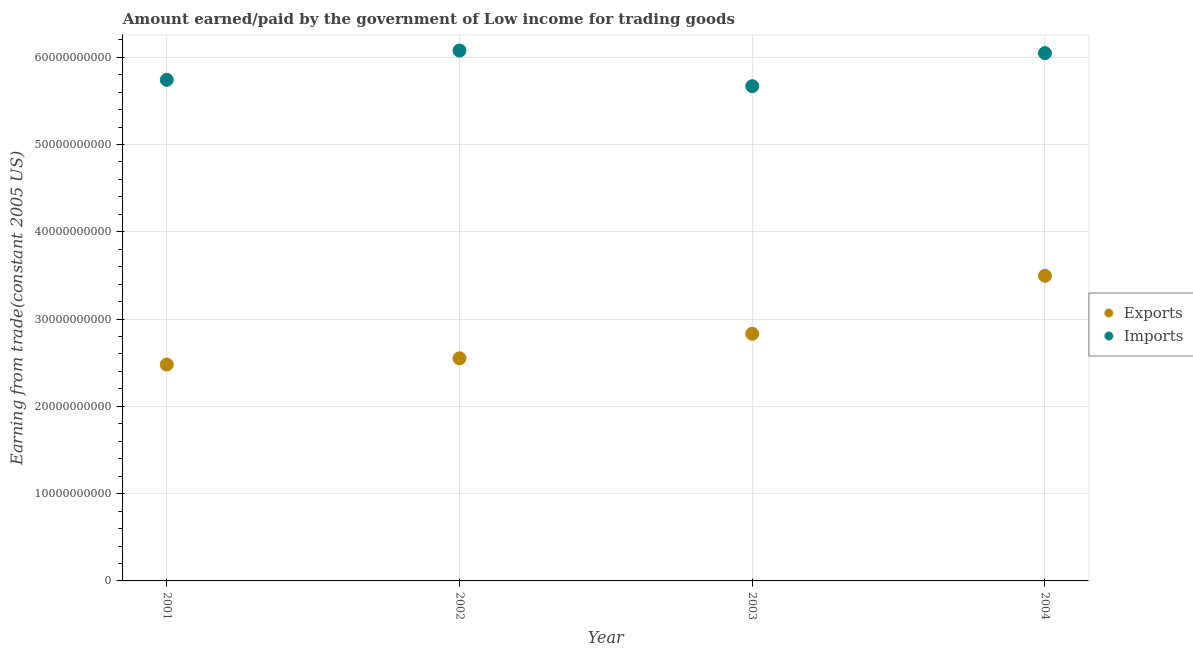What is the amount earned from exports in 2002?
Offer a terse response. 2.55e+1. Across all years, what is the maximum amount earned from exports?
Offer a very short reply. 3.50e+1. Across all years, what is the minimum amount paid for imports?
Provide a succinct answer. 5.67e+1. In which year was the amount paid for imports maximum?
Keep it short and to the point. 2002. In which year was the amount earned from exports minimum?
Provide a short and direct response. 2001. What is the total amount paid for imports in the graph?
Ensure brevity in your answer.  2.35e+11. What is the difference between the amount earned from exports in 2002 and that in 2003?
Provide a succinct answer. -2.81e+09. What is the difference between the amount paid for imports in 2003 and the amount earned from exports in 2004?
Keep it short and to the point. 2.17e+1. What is the average amount paid for imports per year?
Offer a terse response. 5.88e+1. In the year 2004, what is the difference between the amount paid for imports and amount earned from exports?
Offer a terse response. 2.55e+1. What is the ratio of the amount earned from exports in 2001 to that in 2004?
Provide a short and direct response. 0.71. Is the amount paid for imports in 2001 less than that in 2004?
Provide a succinct answer. Yes. What is the difference between the highest and the second highest amount earned from exports?
Your answer should be compact. 6.65e+09. What is the difference between the highest and the lowest amount paid for imports?
Keep it short and to the point. 4.08e+09. Is the sum of the amount paid for imports in 2002 and 2003 greater than the maximum amount earned from exports across all years?
Your response must be concise. Yes. Is the amount paid for imports strictly greater than the amount earned from exports over the years?
Make the answer very short. Yes. How many dotlines are there?
Provide a short and direct response. 2. What is the difference between two consecutive major ticks on the Y-axis?
Provide a succinct answer. 1.00e+1. How are the legend labels stacked?
Your answer should be compact. Vertical. What is the title of the graph?
Your answer should be very brief. Amount earned/paid by the government of Low income for trading goods. Does "Age 15+" appear as one of the legend labels in the graph?
Keep it short and to the point. No. What is the label or title of the X-axis?
Provide a succinct answer. Year. What is the label or title of the Y-axis?
Your answer should be very brief. Earning from trade(constant 2005 US). What is the Earning from trade(constant 2005 US) in Exports in 2001?
Offer a very short reply. 2.48e+1. What is the Earning from trade(constant 2005 US) of Imports in 2001?
Keep it short and to the point. 5.74e+1. What is the Earning from trade(constant 2005 US) of Exports in 2002?
Your answer should be very brief. 2.55e+1. What is the Earning from trade(constant 2005 US) of Imports in 2002?
Offer a terse response. 6.08e+1. What is the Earning from trade(constant 2005 US) in Exports in 2003?
Offer a terse response. 2.83e+1. What is the Earning from trade(constant 2005 US) in Imports in 2003?
Keep it short and to the point. 5.67e+1. What is the Earning from trade(constant 2005 US) in Exports in 2004?
Offer a very short reply. 3.50e+1. What is the Earning from trade(constant 2005 US) in Imports in 2004?
Offer a terse response. 6.05e+1. Across all years, what is the maximum Earning from trade(constant 2005 US) of Exports?
Provide a succinct answer. 3.50e+1. Across all years, what is the maximum Earning from trade(constant 2005 US) in Imports?
Make the answer very short. 6.08e+1. Across all years, what is the minimum Earning from trade(constant 2005 US) of Exports?
Your answer should be very brief. 2.48e+1. Across all years, what is the minimum Earning from trade(constant 2005 US) of Imports?
Provide a succinct answer. 5.67e+1. What is the total Earning from trade(constant 2005 US) in Exports in the graph?
Provide a short and direct response. 1.14e+11. What is the total Earning from trade(constant 2005 US) of Imports in the graph?
Provide a succinct answer. 2.35e+11. What is the difference between the Earning from trade(constant 2005 US) of Exports in 2001 and that in 2002?
Ensure brevity in your answer.  -7.19e+08. What is the difference between the Earning from trade(constant 2005 US) of Imports in 2001 and that in 2002?
Give a very brief answer. -3.35e+09. What is the difference between the Earning from trade(constant 2005 US) in Exports in 2001 and that in 2003?
Provide a succinct answer. -3.52e+09. What is the difference between the Earning from trade(constant 2005 US) of Imports in 2001 and that in 2003?
Keep it short and to the point. 7.26e+08. What is the difference between the Earning from trade(constant 2005 US) of Exports in 2001 and that in 2004?
Ensure brevity in your answer.  -1.02e+1. What is the difference between the Earning from trade(constant 2005 US) in Imports in 2001 and that in 2004?
Your answer should be compact. -3.06e+09. What is the difference between the Earning from trade(constant 2005 US) of Exports in 2002 and that in 2003?
Provide a short and direct response. -2.81e+09. What is the difference between the Earning from trade(constant 2005 US) in Imports in 2002 and that in 2003?
Give a very brief answer. 4.08e+09. What is the difference between the Earning from trade(constant 2005 US) in Exports in 2002 and that in 2004?
Provide a succinct answer. -9.45e+09. What is the difference between the Earning from trade(constant 2005 US) of Imports in 2002 and that in 2004?
Your response must be concise. 2.92e+08. What is the difference between the Earning from trade(constant 2005 US) of Exports in 2003 and that in 2004?
Give a very brief answer. -6.65e+09. What is the difference between the Earning from trade(constant 2005 US) of Imports in 2003 and that in 2004?
Give a very brief answer. -3.79e+09. What is the difference between the Earning from trade(constant 2005 US) in Exports in 2001 and the Earning from trade(constant 2005 US) in Imports in 2002?
Make the answer very short. -3.60e+1. What is the difference between the Earning from trade(constant 2005 US) in Exports in 2001 and the Earning from trade(constant 2005 US) in Imports in 2003?
Offer a terse response. -3.19e+1. What is the difference between the Earning from trade(constant 2005 US) in Exports in 2001 and the Earning from trade(constant 2005 US) in Imports in 2004?
Offer a very short reply. -3.57e+1. What is the difference between the Earning from trade(constant 2005 US) in Exports in 2002 and the Earning from trade(constant 2005 US) in Imports in 2003?
Make the answer very short. -3.12e+1. What is the difference between the Earning from trade(constant 2005 US) in Exports in 2002 and the Earning from trade(constant 2005 US) in Imports in 2004?
Make the answer very short. -3.50e+1. What is the difference between the Earning from trade(constant 2005 US) of Exports in 2003 and the Earning from trade(constant 2005 US) of Imports in 2004?
Offer a very short reply. -3.22e+1. What is the average Earning from trade(constant 2005 US) of Exports per year?
Offer a terse response. 2.84e+1. What is the average Earning from trade(constant 2005 US) of Imports per year?
Ensure brevity in your answer.  5.88e+1. In the year 2001, what is the difference between the Earning from trade(constant 2005 US) in Exports and Earning from trade(constant 2005 US) in Imports?
Your response must be concise. -3.26e+1. In the year 2002, what is the difference between the Earning from trade(constant 2005 US) in Exports and Earning from trade(constant 2005 US) in Imports?
Your answer should be very brief. -3.53e+1. In the year 2003, what is the difference between the Earning from trade(constant 2005 US) in Exports and Earning from trade(constant 2005 US) in Imports?
Offer a terse response. -2.84e+1. In the year 2004, what is the difference between the Earning from trade(constant 2005 US) of Exports and Earning from trade(constant 2005 US) of Imports?
Your answer should be compact. -2.55e+1. What is the ratio of the Earning from trade(constant 2005 US) in Exports in 2001 to that in 2002?
Provide a succinct answer. 0.97. What is the ratio of the Earning from trade(constant 2005 US) of Imports in 2001 to that in 2002?
Provide a short and direct response. 0.94. What is the ratio of the Earning from trade(constant 2005 US) of Exports in 2001 to that in 2003?
Offer a terse response. 0.88. What is the ratio of the Earning from trade(constant 2005 US) in Imports in 2001 to that in 2003?
Your answer should be compact. 1.01. What is the ratio of the Earning from trade(constant 2005 US) in Exports in 2001 to that in 2004?
Your response must be concise. 0.71. What is the ratio of the Earning from trade(constant 2005 US) in Imports in 2001 to that in 2004?
Offer a terse response. 0.95. What is the ratio of the Earning from trade(constant 2005 US) of Exports in 2002 to that in 2003?
Your answer should be very brief. 0.9. What is the ratio of the Earning from trade(constant 2005 US) in Imports in 2002 to that in 2003?
Offer a very short reply. 1.07. What is the ratio of the Earning from trade(constant 2005 US) in Exports in 2002 to that in 2004?
Your response must be concise. 0.73. What is the ratio of the Earning from trade(constant 2005 US) in Exports in 2003 to that in 2004?
Provide a short and direct response. 0.81. What is the ratio of the Earning from trade(constant 2005 US) of Imports in 2003 to that in 2004?
Give a very brief answer. 0.94. What is the difference between the highest and the second highest Earning from trade(constant 2005 US) in Exports?
Keep it short and to the point. 6.65e+09. What is the difference between the highest and the second highest Earning from trade(constant 2005 US) in Imports?
Keep it short and to the point. 2.92e+08. What is the difference between the highest and the lowest Earning from trade(constant 2005 US) in Exports?
Your answer should be very brief. 1.02e+1. What is the difference between the highest and the lowest Earning from trade(constant 2005 US) of Imports?
Keep it short and to the point. 4.08e+09. 